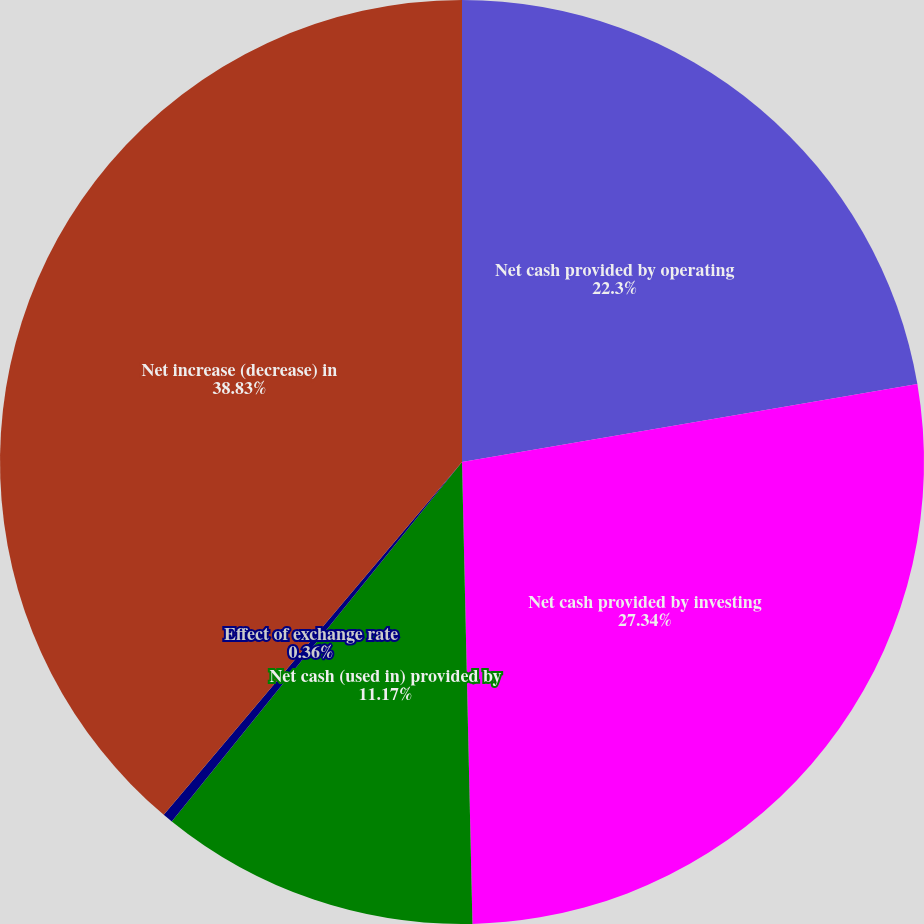<chart> <loc_0><loc_0><loc_500><loc_500><pie_chart><fcel>Net cash provided by operating<fcel>Net cash provided by investing<fcel>Net cash (used in) provided by<fcel>Effect of exchange rate<fcel>Net increase (decrease) in<nl><fcel>22.3%<fcel>27.34%<fcel>11.17%<fcel>0.36%<fcel>38.83%<nl></chart> 